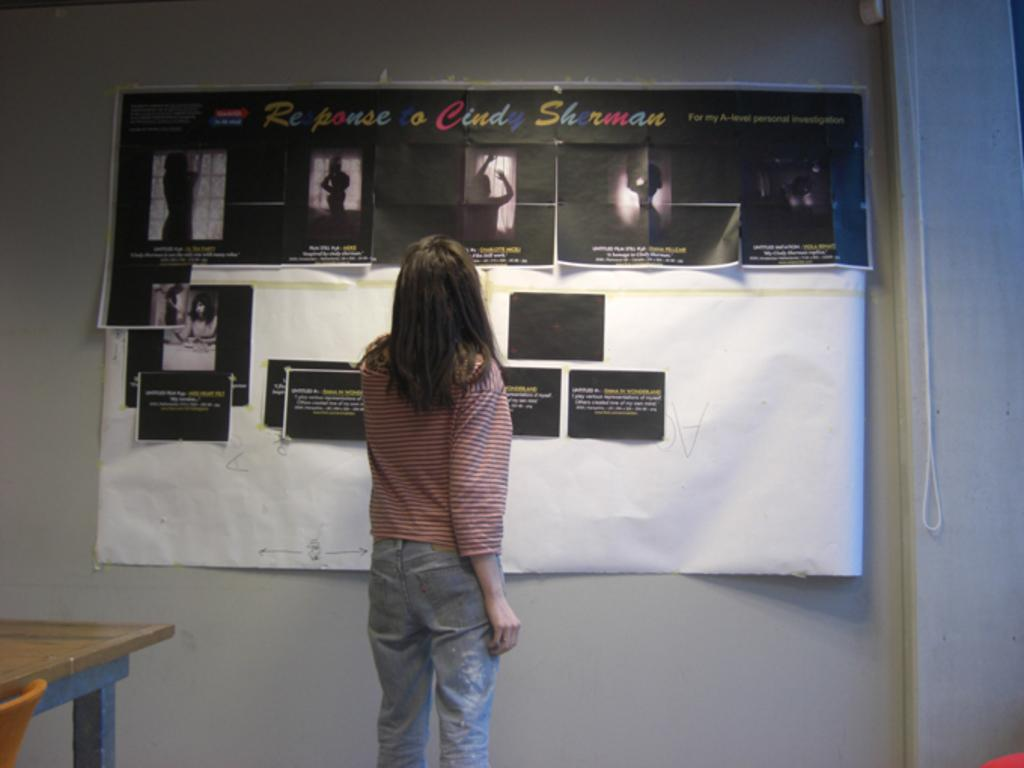What is hanging on the wall in the image? There is a banner with posters on the wall. Who is standing in front of the banner? A woman is standing in front of the banner. What furniture is present in the image? There is a table and a chair in the image. Where is the soap located in the image? There is no soap present in the image. What is the boy doing in the image? There is no boy present in the image. 